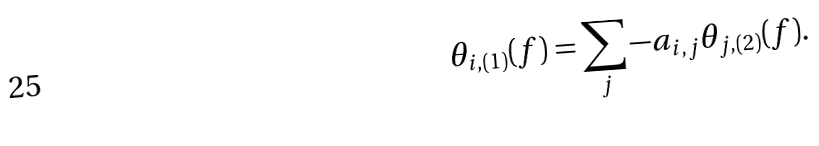<formula> <loc_0><loc_0><loc_500><loc_500>\theta _ { i , ( 1 ) } ( f ) = \sum _ { j } - a _ { i , j } \theta _ { j , ( 2 ) } ( f ) .</formula> 